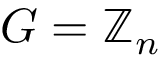<formula> <loc_0><loc_0><loc_500><loc_500>G = \mathbb { Z } _ { n }</formula> 